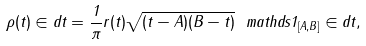<formula> <loc_0><loc_0><loc_500><loc_500>\rho ( t ) \in d t = \frac { 1 } { \pi } r ( t ) \sqrt { ( t - A ) ( B - t ) } \ m a t h d s { 1 } _ { [ A , B ] } \in d t ,</formula> 